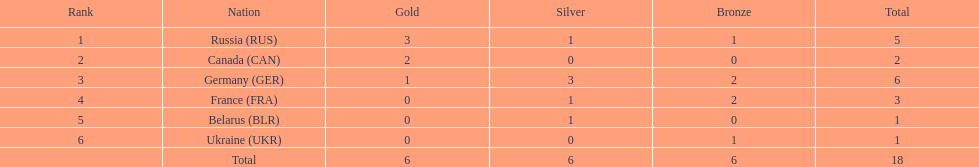During the 1994 winter olympic biathlon, how many silver medals were collectively earned by athletes from france and germany? 4. 